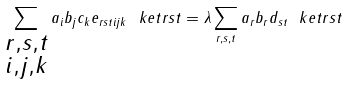<formula> <loc_0><loc_0><loc_500><loc_500>\sum _ { \substack { r , s , t \\ i , j , k } } a _ { i } b _ { j } c _ { k } e _ { r s t i j k } \ k e t { r s t } = \lambda \sum _ { r , s , t } a _ { r } b _ { r } d _ { s t } \ k e t { r s t }</formula> 